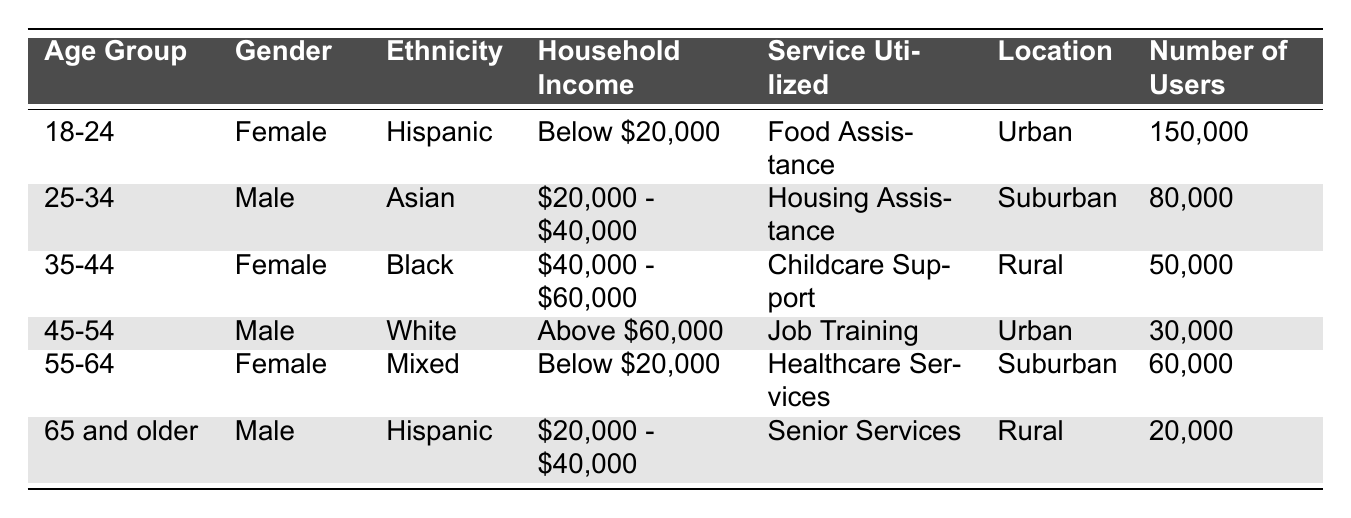What service was utilized by the highest number of users? The service utilized with the highest number of users is "Food Assistance" with 150,000 users.
Answer: Food Assistance How many users are utilizing Housing Assistance? The table indicates that 80,000 users are utilizing Housing Assistance.
Answer: 80,000 Which gender has more users in the 55-64 age group? In the 55-64 age group, there are 60,000 female users and no male users listed, indicating that females have more users.
Answer: Female What is the household income range for the age group 35-44? The household income range for the age group 35-44 is "$40,000 - $60,000" as indicated in the table.
Answer: $40,000 - $60,000 How many total users are in the 25-34 and 35-44 age groups combined? The number of users in the 25-34 age group is 80,000 and in the 35-44 age group is 50,000. Summing these gives 80,000 + 50,000 = 130,000 users.
Answer: 130,000 Does any age group below 55 have users in 'Senior Services'? The table shows that 'Senior Services' is utilized by the age group "65 and older," and there are no users from age groups below 55 in 'Senior Services'. Therefore, the answer is no.
Answer: No What percentage of users in Rural areas utilize Childcare Support? There are 50,000 users utilizing Childcare Support and 20,000 users utilizing Senior Services in Rural areas. Adding these gives a total of 70,000 rural users. The percentage for Childcare Support is (50,000 / 70,000) * 100 = approximately 71.43%.
Answer: 71.43% Are there more users in Urban areas compared to Suburban areas combined for the 18-24 and 45-54 age groups? In the 18-24 age group, there are 150,000 users in Urban areas, and in the 45-54 age group, there are 30,000 users in Urban areas, totaling 180,000 users. For Suburban areas, there are 80,000 users in the 25-34 age group and 60,000 users in the 55-64 age group, totaling 140,000 users. Since 180,000 > 140,000, there are indeed more Urban area users.
Answer: Yes What is the total number of users in all income categories below $20,000? The age groups utilizing services with household incomes below $20,000 include 18-24 with 150,000 users and 55-64 with 60,000 users. Summing these gives 150,000 + 60,000 = 210,000 users.
Answer: 210,000 Which ethnicity has the least number of users in the table? "Hispanic" in the 65 and older age group has 20,000 users, which is less compared to other ethnicities listed. Hence, that is the least number of users by ethnicity.
Answer: Hispanic 